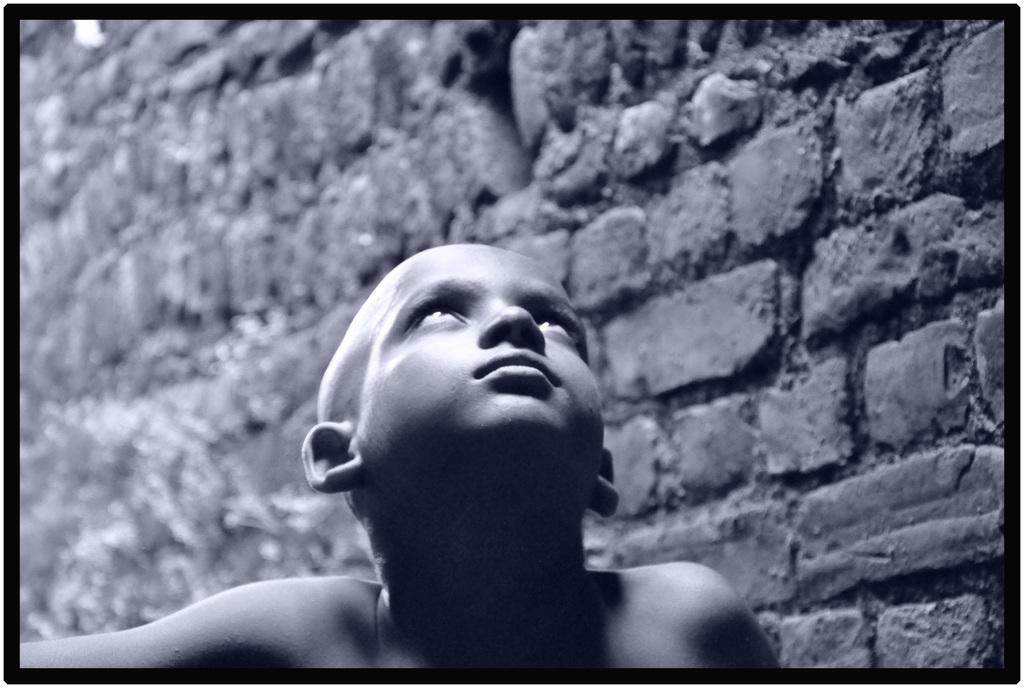What is the main subject in the foreground of the image? There is a boy in the foreground of the image. What is a notable feature of the boy's appearance? The boy has a bold head. What is the color scheme of the image? The image is black and white. What can be seen in the background of the image? There is a brick wall in the background of the image. How does the boy guide the circle in the image? There is no circle present in the image, and the boy is not guiding anything. 